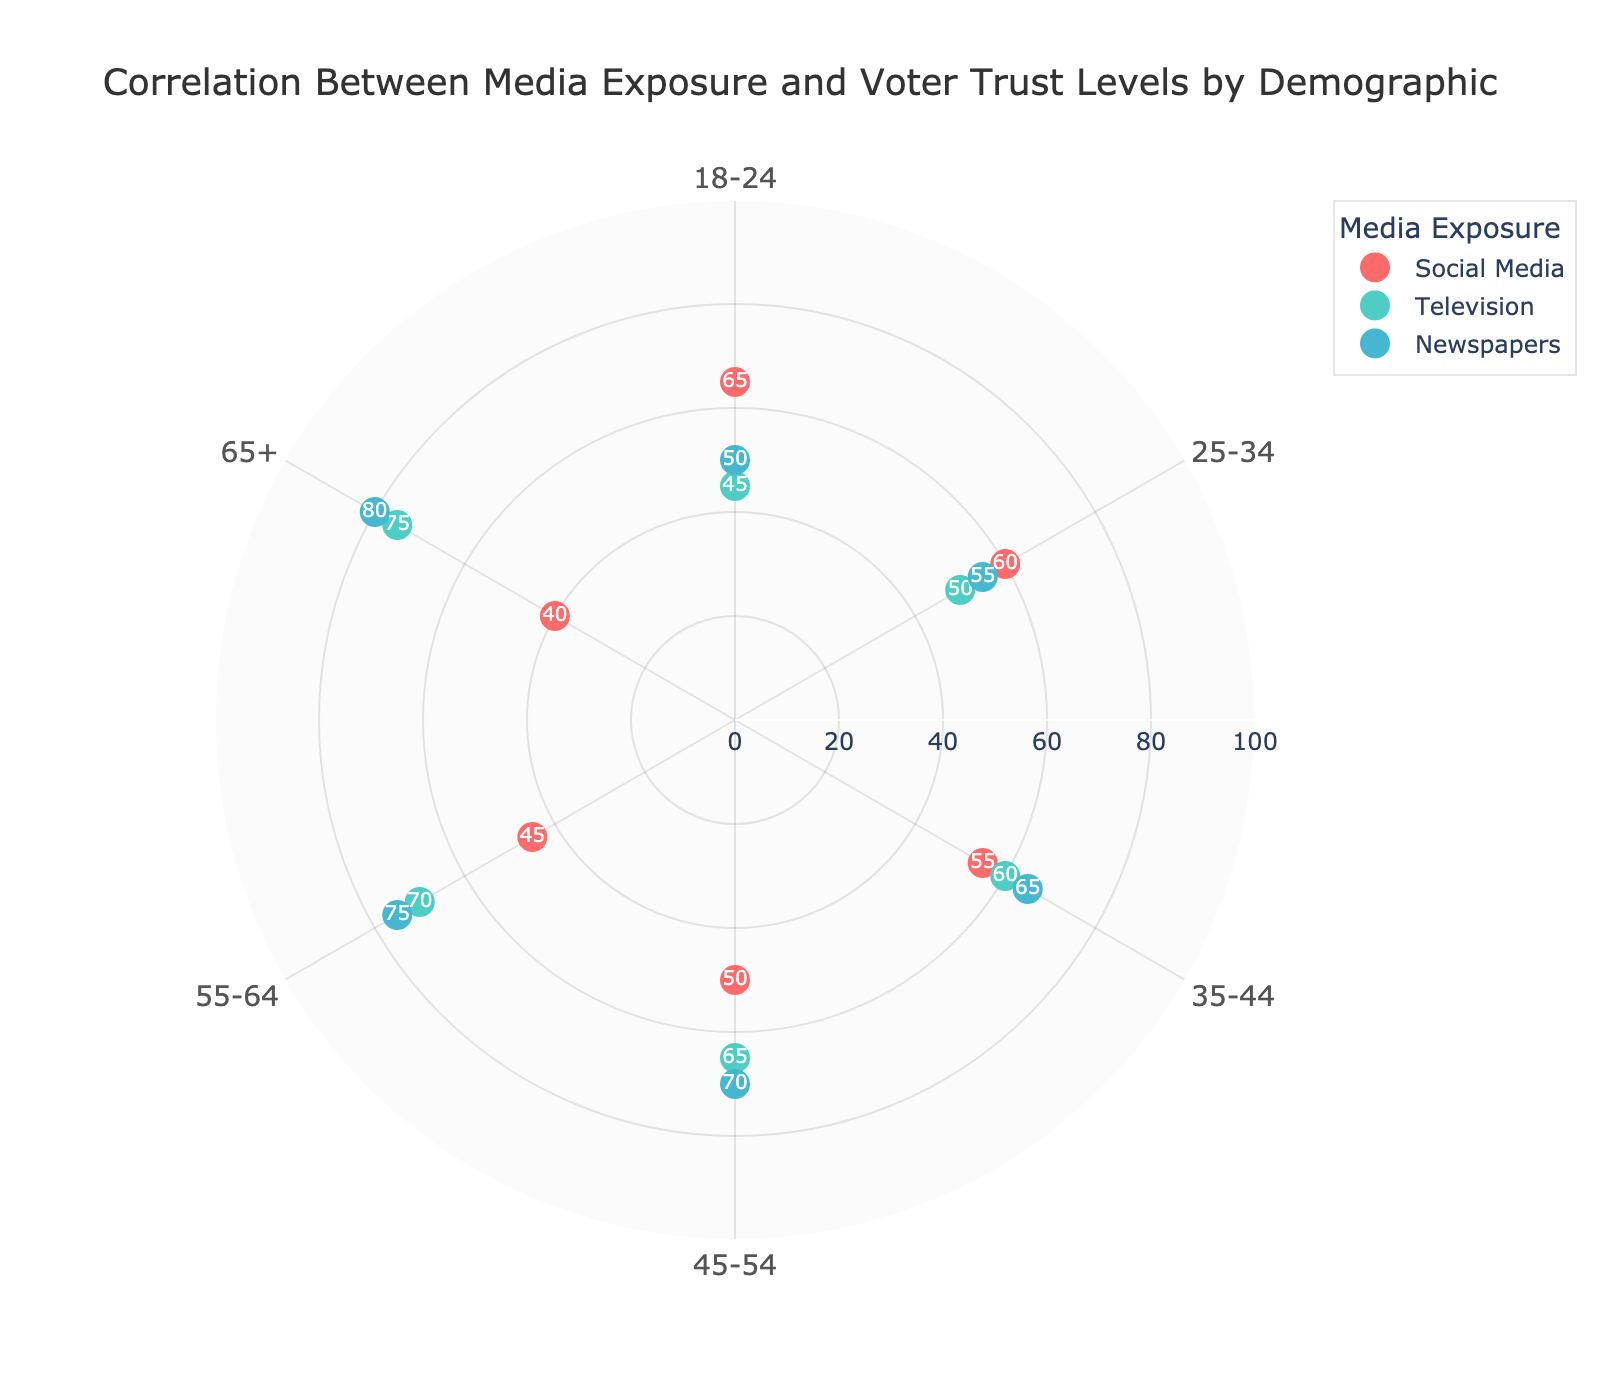What's the title of the figure? The title is located at the top center of the plot and it indicates the main focus of the visual representation. The title helps viewers understand what the chart is about.
Answer: Correlation Between Media Exposure and Voter Trust Levels by Demographic How many demographics are shown in the plot? The demographics are represented along the angular axis of the polar scatter chart. Counting the distinct categories will give us the total number of demographics.
Answer: 5 Which media type has the highest voter trust level among the 65+ demographic group? Locate the 65+ group along the angular axis and find the media type with the highest radial value. Newspapers end at the highest radial point in the 65+ category.
Answer: Newspapers What is the difference in voter trust level between Social Media and Television for the 45-54 demographic? Locate both Social Media and Television points in the 45-54 group and subtract the trust level of Social Media from that of Television: 65 - 50.
Answer: 15 Which demographic group has the lowest trust level for Social Media? Compare the radial positions of Social Media points across all demographic groups. The lowest radial value corresponds to the lowest voter trust. For the 65+ group, the trust level is 40, which is the lowest.
Answer: 65+ What's the average voter trust level for Television across all demographics? Sum the trust levels for Television across all demographics: 45 + 50 + 60 + 65 + 70 + 75 = 365. Then, divide by the number of demographic groups: 365 / 6.
Answer: 60.83 Between Newspapers and Social Media, which has a higher average trust level across all demographics? Compute the average for each media type. Newspapers: (50 + 55 + 65 + 70 + 75 + 80) / 6 = 65.83. Social Media: (65 + 60 + 55 + 50 + 45 + 40) / 6 = 52.5. Compare the two averages.
Answer: Newspapers What is the median trust level for Newspapers across all demographics? Arrange the trust levels for Newspapers in ascending order: 50, 55, 65, 70, 75, 80. The median is the average of the 3rd and 4th values: (65 + 70) / 2.
Answer: 67.5 Which demographic group shows the most variety in voter trust levels across different media types? Examine the range of trust levels for each demographic. The 55-64 group spans from a low of 45 (Social Media) to a high of 75 (Newspapers), showing the widest range of 30.
Answer: 55-64 Is there a demographic group where Television has the lowest voter trust level compared to other media types? For each demographic, compare the trust levels of Television with other media. Television has a lower trust level than other media in the 18-24 demographic only.
Answer: 18-24 